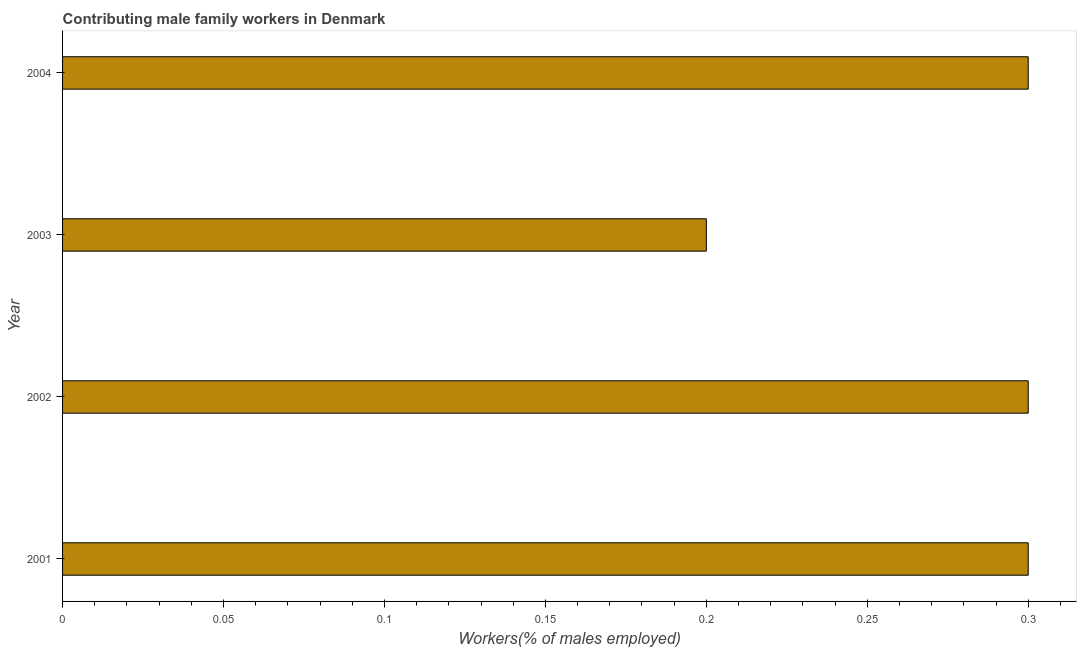Does the graph contain any zero values?
Your answer should be compact. No. What is the title of the graph?
Your answer should be compact. Contributing male family workers in Denmark. What is the label or title of the X-axis?
Offer a terse response. Workers(% of males employed). What is the label or title of the Y-axis?
Your response must be concise. Year. What is the contributing male family workers in 2002?
Keep it short and to the point. 0.3. Across all years, what is the maximum contributing male family workers?
Your answer should be very brief. 0.3. Across all years, what is the minimum contributing male family workers?
Your answer should be very brief. 0.2. In which year was the contributing male family workers maximum?
Your response must be concise. 2001. In which year was the contributing male family workers minimum?
Provide a succinct answer. 2003. What is the sum of the contributing male family workers?
Your response must be concise. 1.1. What is the average contributing male family workers per year?
Your answer should be very brief. 0.28. What is the median contributing male family workers?
Your answer should be very brief. 0.3. In how many years, is the contributing male family workers greater than 0.26 %?
Provide a succinct answer. 3. Is the sum of the contributing male family workers in 2002 and 2004 greater than the maximum contributing male family workers across all years?
Provide a succinct answer. Yes. In how many years, is the contributing male family workers greater than the average contributing male family workers taken over all years?
Keep it short and to the point. 3. How many bars are there?
Make the answer very short. 4. Are the values on the major ticks of X-axis written in scientific E-notation?
Your response must be concise. No. What is the Workers(% of males employed) in 2001?
Keep it short and to the point. 0.3. What is the Workers(% of males employed) in 2002?
Your response must be concise. 0.3. What is the Workers(% of males employed) of 2003?
Provide a succinct answer. 0.2. What is the Workers(% of males employed) in 2004?
Provide a short and direct response. 0.3. What is the difference between the Workers(% of males employed) in 2001 and 2003?
Your answer should be compact. 0.1. What is the difference between the Workers(% of males employed) in 2001 and 2004?
Your response must be concise. 0. What is the difference between the Workers(% of males employed) in 2003 and 2004?
Offer a very short reply. -0.1. What is the ratio of the Workers(% of males employed) in 2001 to that in 2004?
Give a very brief answer. 1. What is the ratio of the Workers(% of males employed) in 2002 to that in 2003?
Ensure brevity in your answer.  1.5. What is the ratio of the Workers(% of males employed) in 2003 to that in 2004?
Your answer should be compact. 0.67. 